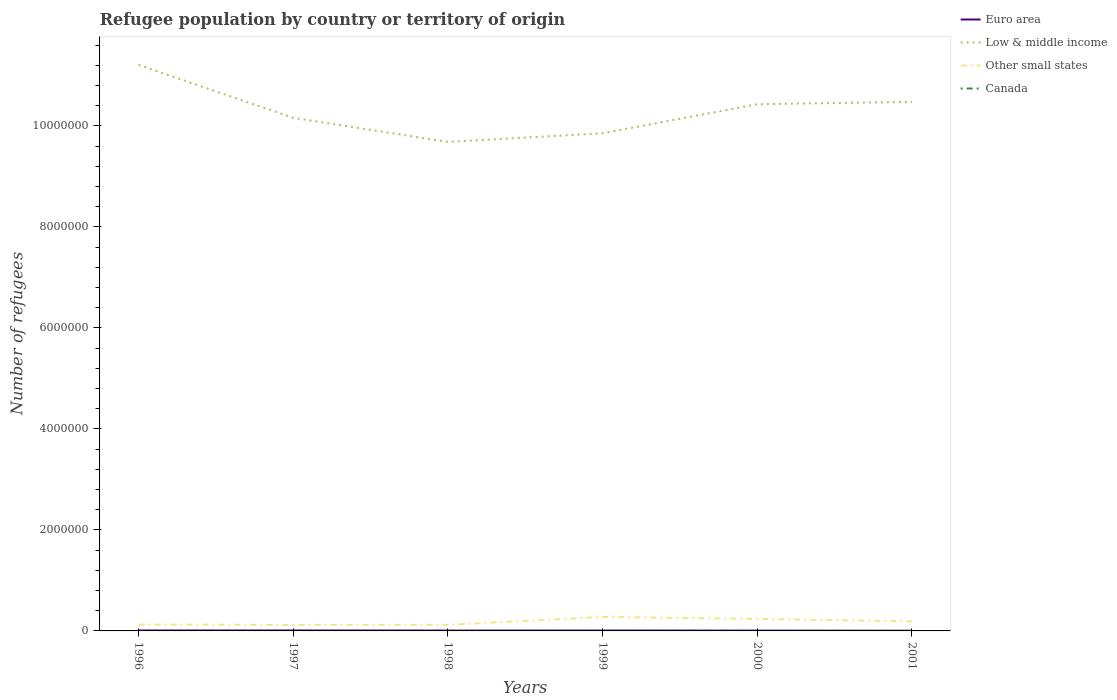Is the number of lines equal to the number of legend labels?
Offer a terse response. Yes. Across all years, what is the maximum number of refugees in Other small states?
Keep it short and to the point. 1.19e+05. In which year was the number of refugees in Other small states maximum?
Keep it short and to the point. 1997. What is the total number of refugees in Euro area in the graph?
Your answer should be very brief. 5194. What is the difference between the highest and the second highest number of refugees in Other small states?
Ensure brevity in your answer.  1.58e+05. What is the difference between the highest and the lowest number of refugees in Other small states?
Your answer should be compact. 3. How many years are there in the graph?
Provide a short and direct response. 6. What is the difference between two consecutive major ticks on the Y-axis?
Your response must be concise. 2.00e+06. Are the values on the major ticks of Y-axis written in scientific E-notation?
Keep it short and to the point. No. How many legend labels are there?
Provide a succinct answer. 4. How are the legend labels stacked?
Your answer should be very brief. Vertical. What is the title of the graph?
Your answer should be very brief. Refugee population by country or territory of origin. What is the label or title of the X-axis?
Make the answer very short. Years. What is the label or title of the Y-axis?
Offer a terse response. Number of refugees. What is the Number of refugees of Euro area in 1996?
Keep it short and to the point. 8800. What is the Number of refugees in Low & middle income in 1996?
Keep it short and to the point. 1.12e+07. What is the Number of refugees of Other small states in 1996?
Keep it short and to the point. 1.27e+05. What is the Number of refugees in Euro area in 1997?
Offer a very short reply. 8703. What is the Number of refugees of Low & middle income in 1997?
Your answer should be very brief. 1.02e+07. What is the Number of refugees in Other small states in 1997?
Make the answer very short. 1.19e+05. What is the Number of refugees of Euro area in 1998?
Give a very brief answer. 6780. What is the Number of refugees in Low & middle income in 1998?
Provide a succinct answer. 9.68e+06. What is the Number of refugees of Other small states in 1998?
Ensure brevity in your answer.  1.21e+05. What is the Number of refugees of Canada in 1998?
Ensure brevity in your answer.  15. What is the Number of refugees of Euro area in 1999?
Your response must be concise. 7053. What is the Number of refugees of Low & middle income in 1999?
Keep it short and to the point. 9.85e+06. What is the Number of refugees in Other small states in 1999?
Your answer should be very brief. 2.77e+05. What is the Number of refugees of Canada in 1999?
Ensure brevity in your answer.  18. What is the Number of refugees in Euro area in 2000?
Offer a terse response. 6254. What is the Number of refugees of Low & middle income in 2000?
Provide a succinct answer. 1.04e+07. What is the Number of refugees of Other small states in 2000?
Offer a terse response. 2.38e+05. What is the Number of refugees in Euro area in 2001?
Offer a terse response. 3606. What is the Number of refugees in Low & middle income in 2001?
Give a very brief answer. 1.05e+07. What is the Number of refugees of Other small states in 2001?
Your response must be concise. 1.89e+05. Across all years, what is the maximum Number of refugees of Euro area?
Provide a short and direct response. 8800. Across all years, what is the maximum Number of refugees in Low & middle income?
Give a very brief answer. 1.12e+07. Across all years, what is the maximum Number of refugees in Other small states?
Your answer should be very brief. 2.77e+05. Across all years, what is the maximum Number of refugees of Canada?
Your answer should be compact. 26. Across all years, what is the minimum Number of refugees in Euro area?
Make the answer very short. 3606. Across all years, what is the minimum Number of refugees in Low & middle income?
Offer a terse response. 9.68e+06. Across all years, what is the minimum Number of refugees of Other small states?
Give a very brief answer. 1.19e+05. What is the total Number of refugees in Euro area in the graph?
Make the answer very short. 4.12e+04. What is the total Number of refugees in Low & middle income in the graph?
Provide a succinct answer. 6.18e+07. What is the total Number of refugees of Other small states in the graph?
Ensure brevity in your answer.  1.07e+06. What is the difference between the Number of refugees of Euro area in 1996 and that in 1997?
Provide a succinct answer. 97. What is the difference between the Number of refugees in Low & middle income in 1996 and that in 1997?
Your response must be concise. 1.05e+06. What is the difference between the Number of refugees of Other small states in 1996 and that in 1997?
Ensure brevity in your answer.  8020. What is the difference between the Number of refugees of Euro area in 1996 and that in 1998?
Keep it short and to the point. 2020. What is the difference between the Number of refugees in Low & middle income in 1996 and that in 1998?
Offer a terse response. 1.53e+06. What is the difference between the Number of refugees in Other small states in 1996 and that in 1998?
Make the answer very short. 5884. What is the difference between the Number of refugees of Euro area in 1996 and that in 1999?
Give a very brief answer. 1747. What is the difference between the Number of refugees of Low & middle income in 1996 and that in 1999?
Keep it short and to the point. 1.35e+06. What is the difference between the Number of refugees in Other small states in 1996 and that in 1999?
Your answer should be very brief. -1.50e+05. What is the difference between the Number of refugees in Euro area in 1996 and that in 2000?
Keep it short and to the point. 2546. What is the difference between the Number of refugees of Low & middle income in 1996 and that in 2000?
Provide a short and direct response. 7.79e+05. What is the difference between the Number of refugees in Other small states in 1996 and that in 2000?
Ensure brevity in your answer.  -1.11e+05. What is the difference between the Number of refugees of Euro area in 1996 and that in 2001?
Provide a succinct answer. 5194. What is the difference between the Number of refugees in Low & middle income in 1996 and that in 2001?
Offer a terse response. 7.33e+05. What is the difference between the Number of refugees in Other small states in 1996 and that in 2001?
Provide a succinct answer. -6.22e+04. What is the difference between the Number of refugees in Canada in 1996 and that in 2001?
Provide a short and direct response. 4. What is the difference between the Number of refugees in Euro area in 1997 and that in 1998?
Provide a succinct answer. 1923. What is the difference between the Number of refugees of Low & middle income in 1997 and that in 1998?
Give a very brief answer. 4.77e+05. What is the difference between the Number of refugees of Other small states in 1997 and that in 1998?
Your answer should be very brief. -2136. What is the difference between the Number of refugees in Euro area in 1997 and that in 1999?
Offer a terse response. 1650. What is the difference between the Number of refugees in Low & middle income in 1997 and that in 1999?
Offer a very short reply. 3.05e+05. What is the difference between the Number of refugees of Other small states in 1997 and that in 1999?
Give a very brief answer. -1.58e+05. What is the difference between the Number of refugees in Canada in 1997 and that in 1999?
Offer a very short reply. -7. What is the difference between the Number of refugees in Euro area in 1997 and that in 2000?
Offer a terse response. 2449. What is the difference between the Number of refugees in Low & middle income in 1997 and that in 2000?
Your answer should be compact. -2.70e+05. What is the difference between the Number of refugees in Other small states in 1997 and that in 2000?
Offer a terse response. -1.19e+05. What is the difference between the Number of refugees in Euro area in 1997 and that in 2001?
Provide a succinct answer. 5097. What is the difference between the Number of refugees of Low & middle income in 1997 and that in 2001?
Provide a short and direct response. -3.16e+05. What is the difference between the Number of refugees of Other small states in 1997 and that in 2001?
Keep it short and to the point. -7.02e+04. What is the difference between the Number of refugees in Euro area in 1998 and that in 1999?
Offer a very short reply. -273. What is the difference between the Number of refugees of Low & middle income in 1998 and that in 1999?
Offer a terse response. -1.71e+05. What is the difference between the Number of refugees in Other small states in 1998 and that in 1999?
Make the answer very short. -1.56e+05. What is the difference between the Number of refugees in Canada in 1998 and that in 1999?
Provide a succinct answer. -3. What is the difference between the Number of refugees of Euro area in 1998 and that in 2000?
Give a very brief answer. 526. What is the difference between the Number of refugees of Low & middle income in 1998 and that in 2000?
Provide a short and direct response. -7.46e+05. What is the difference between the Number of refugees of Other small states in 1998 and that in 2000?
Keep it short and to the point. -1.17e+05. What is the difference between the Number of refugees in Canada in 1998 and that in 2000?
Provide a succinct answer. -11. What is the difference between the Number of refugees of Euro area in 1998 and that in 2001?
Offer a very short reply. 3174. What is the difference between the Number of refugees of Low & middle income in 1998 and that in 2001?
Make the answer very short. -7.93e+05. What is the difference between the Number of refugees of Other small states in 1998 and that in 2001?
Provide a short and direct response. -6.81e+04. What is the difference between the Number of refugees of Euro area in 1999 and that in 2000?
Provide a short and direct response. 799. What is the difference between the Number of refugees in Low & middle income in 1999 and that in 2000?
Make the answer very short. -5.75e+05. What is the difference between the Number of refugees of Other small states in 1999 and that in 2000?
Make the answer very short. 3.95e+04. What is the difference between the Number of refugees in Canada in 1999 and that in 2000?
Your answer should be compact. -8. What is the difference between the Number of refugees in Euro area in 1999 and that in 2001?
Give a very brief answer. 3447. What is the difference between the Number of refugees of Low & middle income in 1999 and that in 2001?
Your answer should be compact. -6.21e+05. What is the difference between the Number of refugees of Other small states in 1999 and that in 2001?
Provide a succinct answer. 8.82e+04. What is the difference between the Number of refugees of Canada in 1999 and that in 2001?
Keep it short and to the point. 14. What is the difference between the Number of refugees of Euro area in 2000 and that in 2001?
Offer a terse response. 2648. What is the difference between the Number of refugees in Low & middle income in 2000 and that in 2001?
Your response must be concise. -4.63e+04. What is the difference between the Number of refugees in Other small states in 2000 and that in 2001?
Your response must be concise. 4.87e+04. What is the difference between the Number of refugees of Euro area in 1996 and the Number of refugees of Low & middle income in 1997?
Offer a terse response. -1.02e+07. What is the difference between the Number of refugees in Euro area in 1996 and the Number of refugees in Other small states in 1997?
Your answer should be very brief. -1.10e+05. What is the difference between the Number of refugees in Euro area in 1996 and the Number of refugees in Canada in 1997?
Provide a short and direct response. 8789. What is the difference between the Number of refugees of Low & middle income in 1996 and the Number of refugees of Other small states in 1997?
Keep it short and to the point. 1.11e+07. What is the difference between the Number of refugees of Low & middle income in 1996 and the Number of refugees of Canada in 1997?
Keep it short and to the point. 1.12e+07. What is the difference between the Number of refugees of Other small states in 1996 and the Number of refugees of Canada in 1997?
Make the answer very short. 1.27e+05. What is the difference between the Number of refugees of Euro area in 1996 and the Number of refugees of Low & middle income in 1998?
Your answer should be very brief. -9.67e+06. What is the difference between the Number of refugees in Euro area in 1996 and the Number of refugees in Other small states in 1998?
Provide a succinct answer. -1.12e+05. What is the difference between the Number of refugees of Euro area in 1996 and the Number of refugees of Canada in 1998?
Offer a very short reply. 8785. What is the difference between the Number of refugees in Low & middle income in 1996 and the Number of refugees in Other small states in 1998?
Give a very brief answer. 1.11e+07. What is the difference between the Number of refugees in Low & middle income in 1996 and the Number of refugees in Canada in 1998?
Provide a short and direct response. 1.12e+07. What is the difference between the Number of refugees in Other small states in 1996 and the Number of refugees in Canada in 1998?
Offer a terse response. 1.27e+05. What is the difference between the Number of refugees in Euro area in 1996 and the Number of refugees in Low & middle income in 1999?
Your answer should be compact. -9.84e+06. What is the difference between the Number of refugees of Euro area in 1996 and the Number of refugees of Other small states in 1999?
Your answer should be very brief. -2.68e+05. What is the difference between the Number of refugees in Euro area in 1996 and the Number of refugees in Canada in 1999?
Offer a very short reply. 8782. What is the difference between the Number of refugees of Low & middle income in 1996 and the Number of refugees of Other small states in 1999?
Offer a terse response. 1.09e+07. What is the difference between the Number of refugees of Low & middle income in 1996 and the Number of refugees of Canada in 1999?
Give a very brief answer. 1.12e+07. What is the difference between the Number of refugees in Other small states in 1996 and the Number of refugees in Canada in 1999?
Your response must be concise. 1.27e+05. What is the difference between the Number of refugees of Euro area in 1996 and the Number of refugees of Low & middle income in 2000?
Your answer should be compact. -1.04e+07. What is the difference between the Number of refugees of Euro area in 1996 and the Number of refugees of Other small states in 2000?
Offer a very short reply. -2.29e+05. What is the difference between the Number of refugees in Euro area in 1996 and the Number of refugees in Canada in 2000?
Provide a short and direct response. 8774. What is the difference between the Number of refugees of Low & middle income in 1996 and the Number of refugees of Other small states in 2000?
Make the answer very short. 1.10e+07. What is the difference between the Number of refugees of Low & middle income in 1996 and the Number of refugees of Canada in 2000?
Offer a terse response. 1.12e+07. What is the difference between the Number of refugees in Other small states in 1996 and the Number of refugees in Canada in 2000?
Offer a very short reply. 1.27e+05. What is the difference between the Number of refugees in Euro area in 1996 and the Number of refugees in Low & middle income in 2001?
Offer a very short reply. -1.05e+07. What is the difference between the Number of refugees in Euro area in 1996 and the Number of refugees in Other small states in 2001?
Your response must be concise. -1.80e+05. What is the difference between the Number of refugees of Euro area in 1996 and the Number of refugees of Canada in 2001?
Give a very brief answer. 8796. What is the difference between the Number of refugees of Low & middle income in 1996 and the Number of refugees of Other small states in 2001?
Offer a terse response. 1.10e+07. What is the difference between the Number of refugees of Low & middle income in 1996 and the Number of refugees of Canada in 2001?
Keep it short and to the point. 1.12e+07. What is the difference between the Number of refugees of Other small states in 1996 and the Number of refugees of Canada in 2001?
Provide a short and direct response. 1.27e+05. What is the difference between the Number of refugees of Euro area in 1997 and the Number of refugees of Low & middle income in 1998?
Your answer should be very brief. -9.67e+06. What is the difference between the Number of refugees in Euro area in 1997 and the Number of refugees in Other small states in 1998?
Keep it short and to the point. -1.12e+05. What is the difference between the Number of refugees in Euro area in 1997 and the Number of refugees in Canada in 1998?
Your response must be concise. 8688. What is the difference between the Number of refugees in Low & middle income in 1997 and the Number of refugees in Other small states in 1998?
Offer a terse response. 1.00e+07. What is the difference between the Number of refugees in Low & middle income in 1997 and the Number of refugees in Canada in 1998?
Make the answer very short. 1.02e+07. What is the difference between the Number of refugees of Other small states in 1997 and the Number of refugees of Canada in 1998?
Give a very brief answer. 1.19e+05. What is the difference between the Number of refugees in Euro area in 1997 and the Number of refugees in Low & middle income in 1999?
Make the answer very short. -9.85e+06. What is the difference between the Number of refugees in Euro area in 1997 and the Number of refugees in Other small states in 1999?
Keep it short and to the point. -2.68e+05. What is the difference between the Number of refugees in Euro area in 1997 and the Number of refugees in Canada in 1999?
Your answer should be compact. 8685. What is the difference between the Number of refugees in Low & middle income in 1997 and the Number of refugees in Other small states in 1999?
Provide a succinct answer. 9.88e+06. What is the difference between the Number of refugees of Low & middle income in 1997 and the Number of refugees of Canada in 1999?
Your response must be concise. 1.02e+07. What is the difference between the Number of refugees in Other small states in 1997 and the Number of refugees in Canada in 1999?
Your answer should be compact. 1.19e+05. What is the difference between the Number of refugees of Euro area in 1997 and the Number of refugees of Low & middle income in 2000?
Keep it short and to the point. -1.04e+07. What is the difference between the Number of refugees in Euro area in 1997 and the Number of refugees in Other small states in 2000?
Your answer should be very brief. -2.29e+05. What is the difference between the Number of refugees of Euro area in 1997 and the Number of refugees of Canada in 2000?
Ensure brevity in your answer.  8677. What is the difference between the Number of refugees in Low & middle income in 1997 and the Number of refugees in Other small states in 2000?
Your answer should be compact. 9.92e+06. What is the difference between the Number of refugees of Low & middle income in 1997 and the Number of refugees of Canada in 2000?
Offer a very short reply. 1.02e+07. What is the difference between the Number of refugees of Other small states in 1997 and the Number of refugees of Canada in 2000?
Your answer should be compact. 1.19e+05. What is the difference between the Number of refugees of Euro area in 1997 and the Number of refugees of Low & middle income in 2001?
Your response must be concise. -1.05e+07. What is the difference between the Number of refugees in Euro area in 1997 and the Number of refugees in Other small states in 2001?
Make the answer very short. -1.80e+05. What is the difference between the Number of refugees in Euro area in 1997 and the Number of refugees in Canada in 2001?
Your answer should be compact. 8699. What is the difference between the Number of refugees of Low & middle income in 1997 and the Number of refugees of Other small states in 2001?
Your answer should be very brief. 9.97e+06. What is the difference between the Number of refugees in Low & middle income in 1997 and the Number of refugees in Canada in 2001?
Keep it short and to the point. 1.02e+07. What is the difference between the Number of refugees of Other small states in 1997 and the Number of refugees of Canada in 2001?
Offer a terse response. 1.19e+05. What is the difference between the Number of refugees in Euro area in 1998 and the Number of refugees in Low & middle income in 1999?
Your answer should be very brief. -9.85e+06. What is the difference between the Number of refugees of Euro area in 1998 and the Number of refugees of Other small states in 1999?
Ensure brevity in your answer.  -2.70e+05. What is the difference between the Number of refugees of Euro area in 1998 and the Number of refugees of Canada in 1999?
Provide a short and direct response. 6762. What is the difference between the Number of refugees of Low & middle income in 1998 and the Number of refugees of Other small states in 1999?
Offer a very short reply. 9.41e+06. What is the difference between the Number of refugees in Low & middle income in 1998 and the Number of refugees in Canada in 1999?
Keep it short and to the point. 9.68e+06. What is the difference between the Number of refugees in Other small states in 1998 and the Number of refugees in Canada in 1999?
Provide a succinct answer. 1.21e+05. What is the difference between the Number of refugees of Euro area in 1998 and the Number of refugees of Low & middle income in 2000?
Ensure brevity in your answer.  -1.04e+07. What is the difference between the Number of refugees in Euro area in 1998 and the Number of refugees in Other small states in 2000?
Make the answer very short. -2.31e+05. What is the difference between the Number of refugees in Euro area in 1998 and the Number of refugees in Canada in 2000?
Your answer should be compact. 6754. What is the difference between the Number of refugees in Low & middle income in 1998 and the Number of refugees in Other small states in 2000?
Give a very brief answer. 9.44e+06. What is the difference between the Number of refugees of Low & middle income in 1998 and the Number of refugees of Canada in 2000?
Give a very brief answer. 9.68e+06. What is the difference between the Number of refugees in Other small states in 1998 and the Number of refugees in Canada in 2000?
Your response must be concise. 1.21e+05. What is the difference between the Number of refugees in Euro area in 1998 and the Number of refugees in Low & middle income in 2001?
Offer a very short reply. -1.05e+07. What is the difference between the Number of refugees in Euro area in 1998 and the Number of refugees in Other small states in 2001?
Keep it short and to the point. -1.82e+05. What is the difference between the Number of refugees in Euro area in 1998 and the Number of refugees in Canada in 2001?
Provide a short and direct response. 6776. What is the difference between the Number of refugees of Low & middle income in 1998 and the Number of refugees of Other small states in 2001?
Offer a very short reply. 9.49e+06. What is the difference between the Number of refugees in Low & middle income in 1998 and the Number of refugees in Canada in 2001?
Offer a very short reply. 9.68e+06. What is the difference between the Number of refugees of Other small states in 1998 and the Number of refugees of Canada in 2001?
Provide a short and direct response. 1.21e+05. What is the difference between the Number of refugees of Euro area in 1999 and the Number of refugees of Low & middle income in 2000?
Your answer should be very brief. -1.04e+07. What is the difference between the Number of refugees in Euro area in 1999 and the Number of refugees in Other small states in 2000?
Offer a terse response. -2.31e+05. What is the difference between the Number of refugees of Euro area in 1999 and the Number of refugees of Canada in 2000?
Keep it short and to the point. 7027. What is the difference between the Number of refugees in Low & middle income in 1999 and the Number of refugees in Other small states in 2000?
Your answer should be very brief. 9.62e+06. What is the difference between the Number of refugees of Low & middle income in 1999 and the Number of refugees of Canada in 2000?
Ensure brevity in your answer.  9.85e+06. What is the difference between the Number of refugees of Other small states in 1999 and the Number of refugees of Canada in 2000?
Make the answer very short. 2.77e+05. What is the difference between the Number of refugees in Euro area in 1999 and the Number of refugees in Low & middle income in 2001?
Provide a succinct answer. -1.05e+07. What is the difference between the Number of refugees of Euro area in 1999 and the Number of refugees of Other small states in 2001?
Provide a short and direct response. -1.82e+05. What is the difference between the Number of refugees of Euro area in 1999 and the Number of refugees of Canada in 2001?
Provide a succinct answer. 7049. What is the difference between the Number of refugees in Low & middle income in 1999 and the Number of refugees in Other small states in 2001?
Make the answer very short. 9.66e+06. What is the difference between the Number of refugees in Low & middle income in 1999 and the Number of refugees in Canada in 2001?
Your response must be concise. 9.85e+06. What is the difference between the Number of refugees in Other small states in 1999 and the Number of refugees in Canada in 2001?
Your response must be concise. 2.77e+05. What is the difference between the Number of refugees of Euro area in 2000 and the Number of refugees of Low & middle income in 2001?
Make the answer very short. -1.05e+07. What is the difference between the Number of refugees in Euro area in 2000 and the Number of refugees in Other small states in 2001?
Your answer should be compact. -1.83e+05. What is the difference between the Number of refugees in Euro area in 2000 and the Number of refugees in Canada in 2001?
Offer a very short reply. 6250. What is the difference between the Number of refugees in Low & middle income in 2000 and the Number of refugees in Other small states in 2001?
Offer a terse response. 1.02e+07. What is the difference between the Number of refugees in Low & middle income in 2000 and the Number of refugees in Canada in 2001?
Your response must be concise. 1.04e+07. What is the difference between the Number of refugees of Other small states in 2000 and the Number of refugees of Canada in 2001?
Provide a short and direct response. 2.38e+05. What is the average Number of refugees of Euro area per year?
Ensure brevity in your answer.  6866. What is the average Number of refugees in Low & middle income per year?
Your answer should be compact. 1.03e+07. What is the average Number of refugees in Other small states per year?
Make the answer very short. 1.78e+05. What is the average Number of refugees of Canada per year?
Give a very brief answer. 13.67. In the year 1996, what is the difference between the Number of refugees in Euro area and Number of refugees in Low & middle income?
Offer a terse response. -1.12e+07. In the year 1996, what is the difference between the Number of refugees of Euro area and Number of refugees of Other small states?
Your response must be concise. -1.18e+05. In the year 1996, what is the difference between the Number of refugees in Euro area and Number of refugees in Canada?
Give a very brief answer. 8792. In the year 1996, what is the difference between the Number of refugees of Low & middle income and Number of refugees of Other small states?
Ensure brevity in your answer.  1.11e+07. In the year 1996, what is the difference between the Number of refugees of Low & middle income and Number of refugees of Canada?
Offer a terse response. 1.12e+07. In the year 1996, what is the difference between the Number of refugees in Other small states and Number of refugees in Canada?
Your answer should be very brief. 1.27e+05. In the year 1997, what is the difference between the Number of refugees in Euro area and Number of refugees in Low & middle income?
Offer a terse response. -1.02e+07. In the year 1997, what is the difference between the Number of refugees of Euro area and Number of refugees of Other small states?
Ensure brevity in your answer.  -1.10e+05. In the year 1997, what is the difference between the Number of refugees in Euro area and Number of refugees in Canada?
Your answer should be very brief. 8692. In the year 1997, what is the difference between the Number of refugees in Low & middle income and Number of refugees in Other small states?
Give a very brief answer. 1.00e+07. In the year 1997, what is the difference between the Number of refugees in Low & middle income and Number of refugees in Canada?
Your answer should be compact. 1.02e+07. In the year 1997, what is the difference between the Number of refugees in Other small states and Number of refugees in Canada?
Your response must be concise. 1.19e+05. In the year 1998, what is the difference between the Number of refugees in Euro area and Number of refugees in Low & middle income?
Give a very brief answer. -9.68e+06. In the year 1998, what is the difference between the Number of refugees in Euro area and Number of refugees in Other small states?
Offer a terse response. -1.14e+05. In the year 1998, what is the difference between the Number of refugees in Euro area and Number of refugees in Canada?
Offer a very short reply. 6765. In the year 1998, what is the difference between the Number of refugees in Low & middle income and Number of refugees in Other small states?
Provide a succinct answer. 9.56e+06. In the year 1998, what is the difference between the Number of refugees of Low & middle income and Number of refugees of Canada?
Make the answer very short. 9.68e+06. In the year 1998, what is the difference between the Number of refugees of Other small states and Number of refugees of Canada?
Keep it short and to the point. 1.21e+05. In the year 1999, what is the difference between the Number of refugees of Euro area and Number of refugees of Low & middle income?
Ensure brevity in your answer.  -9.85e+06. In the year 1999, what is the difference between the Number of refugees in Euro area and Number of refugees in Other small states?
Your answer should be compact. -2.70e+05. In the year 1999, what is the difference between the Number of refugees of Euro area and Number of refugees of Canada?
Your answer should be very brief. 7035. In the year 1999, what is the difference between the Number of refugees of Low & middle income and Number of refugees of Other small states?
Your answer should be very brief. 9.58e+06. In the year 1999, what is the difference between the Number of refugees of Low & middle income and Number of refugees of Canada?
Ensure brevity in your answer.  9.85e+06. In the year 1999, what is the difference between the Number of refugees in Other small states and Number of refugees in Canada?
Give a very brief answer. 2.77e+05. In the year 2000, what is the difference between the Number of refugees of Euro area and Number of refugees of Low & middle income?
Your answer should be compact. -1.04e+07. In the year 2000, what is the difference between the Number of refugees of Euro area and Number of refugees of Other small states?
Your answer should be very brief. -2.31e+05. In the year 2000, what is the difference between the Number of refugees of Euro area and Number of refugees of Canada?
Your answer should be compact. 6228. In the year 2000, what is the difference between the Number of refugees in Low & middle income and Number of refugees in Other small states?
Give a very brief answer. 1.02e+07. In the year 2000, what is the difference between the Number of refugees of Low & middle income and Number of refugees of Canada?
Provide a succinct answer. 1.04e+07. In the year 2000, what is the difference between the Number of refugees of Other small states and Number of refugees of Canada?
Your response must be concise. 2.38e+05. In the year 2001, what is the difference between the Number of refugees of Euro area and Number of refugees of Low & middle income?
Keep it short and to the point. -1.05e+07. In the year 2001, what is the difference between the Number of refugees of Euro area and Number of refugees of Other small states?
Keep it short and to the point. -1.85e+05. In the year 2001, what is the difference between the Number of refugees of Euro area and Number of refugees of Canada?
Offer a terse response. 3602. In the year 2001, what is the difference between the Number of refugees in Low & middle income and Number of refugees in Other small states?
Keep it short and to the point. 1.03e+07. In the year 2001, what is the difference between the Number of refugees of Low & middle income and Number of refugees of Canada?
Provide a short and direct response. 1.05e+07. In the year 2001, what is the difference between the Number of refugees in Other small states and Number of refugees in Canada?
Your response must be concise. 1.89e+05. What is the ratio of the Number of refugees in Euro area in 1996 to that in 1997?
Offer a very short reply. 1.01. What is the ratio of the Number of refugees in Low & middle income in 1996 to that in 1997?
Keep it short and to the point. 1.1. What is the ratio of the Number of refugees of Other small states in 1996 to that in 1997?
Ensure brevity in your answer.  1.07. What is the ratio of the Number of refugees in Canada in 1996 to that in 1997?
Make the answer very short. 0.73. What is the ratio of the Number of refugees in Euro area in 1996 to that in 1998?
Ensure brevity in your answer.  1.3. What is the ratio of the Number of refugees of Low & middle income in 1996 to that in 1998?
Offer a very short reply. 1.16. What is the ratio of the Number of refugees in Other small states in 1996 to that in 1998?
Your response must be concise. 1.05. What is the ratio of the Number of refugees of Canada in 1996 to that in 1998?
Your answer should be very brief. 0.53. What is the ratio of the Number of refugees of Euro area in 1996 to that in 1999?
Make the answer very short. 1.25. What is the ratio of the Number of refugees of Low & middle income in 1996 to that in 1999?
Your response must be concise. 1.14. What is the ratio of the Number of refugees of Other small states in 1996 to that in 1999?
Your answer should be very brief. 0.46. What is the ratio of the Number of refugees of Canada in 1996 to that in 1999?
Give a very brief answer. 0.44. What is the ratio of the Number of refugees of Euro area in 1996 to that in 2000?
Your answer should be compact. 1.41. What is the ratio of the Number of refugees in Low & middle income in 1996 to that in 2000?
Your response must be concise. 1.07. What is the ratio of the Number of refugees in Other small states in 1996 to that in 2000?
Provide a succinct answer. 0.53. What is the ratio of the Number of refugees in Canada in 1996 to that in 2000?
Give a very brief answer. 0.31. What is the ratio of the Number of refugees of Euro area in 1996 to that in 2001?
Keep it short and to the point. 2.44. What is the ratio of the Number of refugees of Low & middle income in 1996 to that in 2001?
Ensure brevity in your answer.  1.07. What is the ratio of the Number of refugees in Other small states in 1996 to that in 2001?
Give a very brief answer. 0.67. What is the ratio of the Number of refugees in Canada in 1996 to that in 2001?
Provide a succinct answer. 2. What is the ratio of the Number of refugees in Euro area in 1997 to that in 1998?
Your answer should be compact. 1.28. What is the ratio of the Number of refugees of Low & middle income in 1997 to that in 1998?
Provide a short and direct response. 1.05. What is the ratio of the Number of refugees in Other small states in 1997 to that in 1998?
Keep it short and to the point. 0.98. What is the ratio of the Number of refugees of Canada in 1997 to that in 1998?
Your response must be concise. 0.73. What is the ratio of the Number of refugees of Euro area in 1997 to that in 1999?
Your answer should be very brief. 1.23. What is the ratio of the Number of refugees of Low & middle income in 1997 to that in 1999?
Give a very brief answer. 1.03. What is the ratio of the Number of refugees of Other small states in 1997 to that in 1999?
Ensure brevity in your answer.  0.43. What is the ratio of the Number of refugees in Canada in 1997 to that in 1999?
Your response must be concise. 0.61. What is the ratio of the Number of refugees in Euro area in 1997 to that in 2000?
Provide a short and direct response. 1.39. What is the ratio of the Number of refugees of Low & middle income in 1997 to that in 2000?
Provide a succinct answer. 0.97. What is the ratio of the Number of refugees of Other small states in 1997 to that in 2000?
Make the answer very short. 0.5. What is the ratio of the Number of refugees in Canada in 1997 to that in 2000?
Your response must be concise. 0.42. What is the ratio of the Number of refugees in Euro area in 1997 to that in 2001?
Keep it short and to the point. 2.41. What is the ratio of the Number of refugees in Low & middle income in 1997 to that in 2001?
Give a very brief answer. 0.97. What is the ratio of the Number of refugees of Other small states in 1997 to that in 2001?
Offer a very short reply. 0.63. What is the ratio of the Number of refugees of Canada in 1997 to that in 2001?
Your answer should be very brief. 2.75. What is the ratio of the Number of refugees in Euro area in 1998 to that in 1999?
Offer a very short reply. 0.96. What is the ratio of the Number of refugees of Low & middle income in 1998 to that in 1999?
Offer a very short reply. 0.98. What is the ratio of the Number of refugees in Other small states in 1998 to that in 1999?
Your response must be concise. 0.44. What is the ratio of the Number of refugees in Euro area in 1998 to that in 2000?
Offer a terse response. 1.08. What is the ratio of the Number of refugees in Low & middle income in 1998 to that in 2000?
Ensure brevity in your answer.  0.93. What is the ratio of the Number of refugees of Other small states in 1998 to that in 2000?
Your answer should be very brief. 0.51. What is the ratio of the Number of refugees in Canada in 1998 to that in 2000?
Your response must be concise. 0.58. What is the ratio of the Number of refugees in Euro area in 1998 to that in 2001?
Ensure brevity in your answer.  1.88. What is the ratio of the Number of refugees in Low & middle income in 1998 to that in 2001?
Give a very brief answer. 0.92. What is the ratio of the Number of refugees in Other small states in 1998 to that in 2001?
Your answer should be compact. 0.64. What is the ratio of the Number of refugees in Canada in 1998 to that in 2001?
Keep it short and to the point. 3.75. What is the ratio of the Number of refugees of Euro area in 1999 to that in 2000?
Your answer should be compact. 1.13. What is the ratio of the Number of refugees of Low & middle income in 1999 to that in 2000?
Give a very brief answer. 0.94. What is the ratio of the Number of refugees of Other small states in 1999 to that in 2000?
Offer a very short reply. 1.17. What is the ratio of the Number of refugees in Canada in 1999 to that in 2000?
Your answer should be very brief. 0.69. What is the ratio of the Number of refugees in Euro area in 1999 to that in 2001?
Your response must be concise. 1.96. What is the ratio of the Number of refugees of Low & middle income in 1999 to that in 2001?
Provide a short and direct response. 0.94. What is the ratio of the Number of refugees in Other small states in 1999 to that in 2001?
Your answer should be compact. 1.47. What is the ratio of the Number of refugees in Euro area in 2000 to that in 2001?
Give a very brief answer. 1.73. What is the ratio of the Number of refugees in Low & middle income in 2000 to that in 2001?
Offer a very short reply. 1. What is the ratio of the Number of refugees of Other small states in 2000 to that in 2001?
Keep it short and to the point. 1.26. What is the ratio of the Number of refugees in Canada in 2000 to that in 2001?
Provide a succinct answer. 6.5. What is the difference between the highest and the second highest Number of refugees of Euro area?
Provide a short and direct response. 97. What is the difference between the highest and the second highest Number of refugees of Low & middle income?
Ensure brevity in your answer.  7.33e+05. What is the difference between the highest and the second highest Number of refugees in Other small states?
Provide a short and direct response. 3.95e+04. What is the difference between the highest and the lowest Number of refugees in Euro area?
Give a very brief answer. 5194. What is the difference between the highest and the lowest Number of refugees in Low & middle income?
Your answer should be very brief. 1.53e+06. What is the difference between the highest and the lowest Number of refugees of Other small states?
Your answer should be compact. 1.58e+05. 